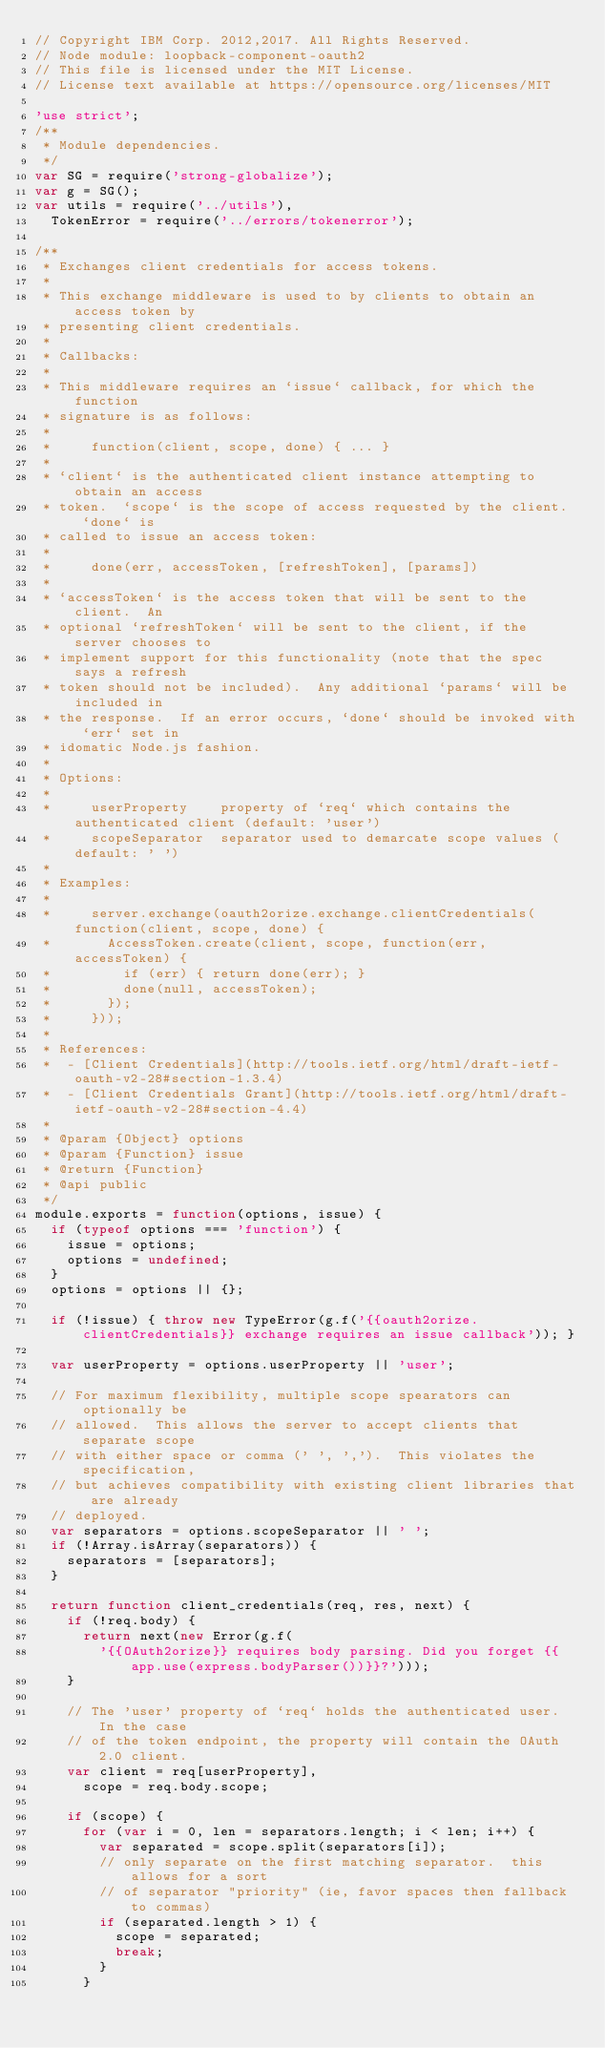<code> <loc_0><loc_0><loc_500><loc_500><_JavaScript_>// Copyright IBM Corp. 2012,2017. All Rights Reserved.
// Node module: loopback-component-oauth2
// This file is licensed under the MIT License.
// License text available at https://opensource.org/licenses/MIT

'use strict';
/**
 * Module dependencies.
 */
var SG = require('strong-globalize');
var g = SG();
var utils = require('../utils'),
  TokenError = require('../errors/tokenerror');

/**
 * Exchanges client credentials for access tokens.
 *
 * This exchange middleware is used to by clients to obtain an access token by
 * presenting client credentials.
 *
 * Callbacks:
 *
 * This middleware requires an `issue` callback, for which the function
 * signature is as follows:
 *
 *     function(client, scope, done) { ... }
 *
 * `client` is the authenticated client instance attempting to obtain an access
 * token.  `scope` is the scope of access requested by the client.  `done` is
 * called to issue an access token:
 *
 *     done(err, accessToken, [refreshToken], [params])
 *
 * `accessToken` is the access token that will be sent to the client.  An
 * optional `refreshToken` will be sent to the client, if the server chooses to
 * implement support for this functionality (note that the spec says a refresh
 * token should not be included).  Any additional `params` will be included in
 * the response.  If an error occurs, `done` should be invoked with `err` set in
 * idomatic Node.js fashion.
 *
 * Options:
 *
 *     userProperty    property of `req` which contains the authenticated client (default: 'user')
 *     scopeSeparator  separator used to demarcate scope values (default: ' ')
 *
 * Examples:
 *
 *     server.exchange(oauth2orize.exchange.clientCredentials(function(client, scope, done) {
 *       AccessToken.create(client, scope, function(err, accessToken) {
 *         if (err) { return done(err); }
 *         done(null, accessToken);
 *       });
 *     }));
 *
 * References:
 *  - [Client Credentials](http://tools.ietf.org/html/draft-ietf-oauth-v2-28#section-1.3.4)
 *  - [Client Credentials Grant](http://tools.ietf.org/html/draft-ietf-oauth-v2-28#section-4.4)
 *
 * @param {Object} options
 * @param {Function} issue
 * @return {Function}
 * @api public
 */
module.exports = function(options, issue) {
  if (typeof options === 'function') {
    issue = options;
    options = undefined;
  }
  options = options || {};

  if (!issue) { throw new TypeError(g.f('{{oauth2orize.clientCredentials}} exchange requires an issue callback')); }

  var userProperty = options.userProperty || 'user';

  // For maximum flexibility, multiple scope spearators can optionally be
  // allowed.  This allows the server to accept clients that separate scope
  // with either space or comma (' ', ',').  This violates the specification,
  // but achieves compatibility with existing client libraries that are already
  // deployed.
  var separators = options.scopeSeparator || ' ';
  if (!Array.isArray(separators)) {
    separators = [separators];
  }

  return function client_credentials(req, res, next) {
    if (!req.body) {
      return next(new Error(g.f(
        '{{OAuth2orize}} requires body parsing. Did you forget {{app.use(express.bodyParser())}}?')));
    }

    // The 'user' property of `req` holds the authenticated user.  In the case
    // of the token endpoint, the property will contain the OAuth 2.0 client.
    var client = req[userProperty],
      scope = req.body.scope;

    if (scope) {
      for (var i = 0, len = separators.length; i < len; i++) {
        var separated = scope.split(separators[i]);
        // only separate on the first matching separator.  this allows for a sort
        // of separator "priority" (ie, favor spaces then fallback to commas)
        if (separated.length > 1) {
          scope = separated;
          break;
        }
      }</code> 